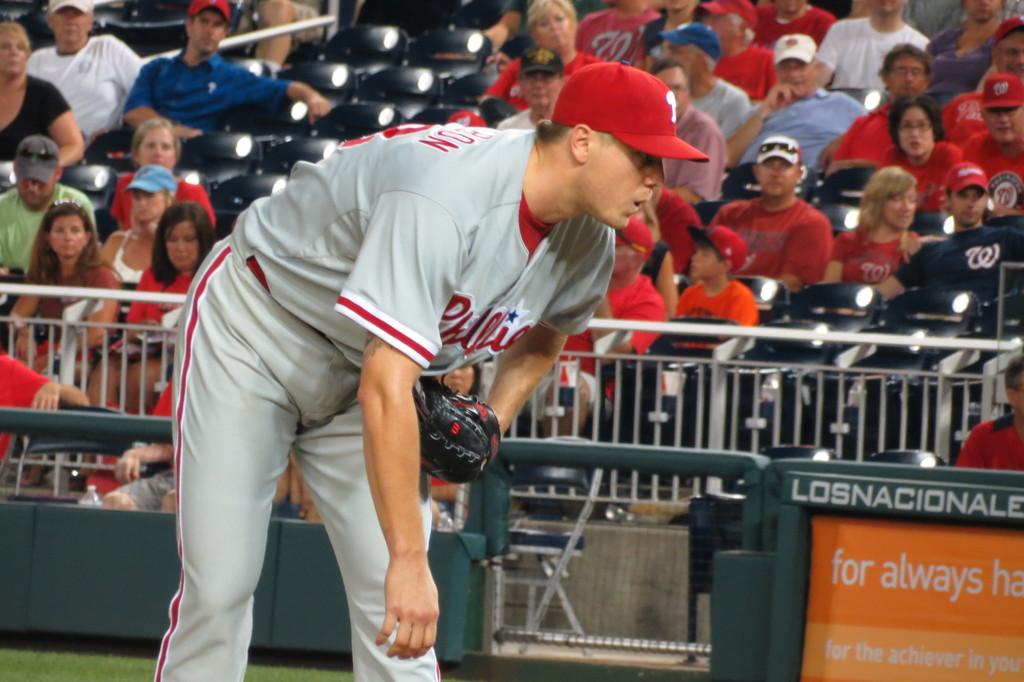What are the words on the orange sign?
Make the answer very short. For always. 